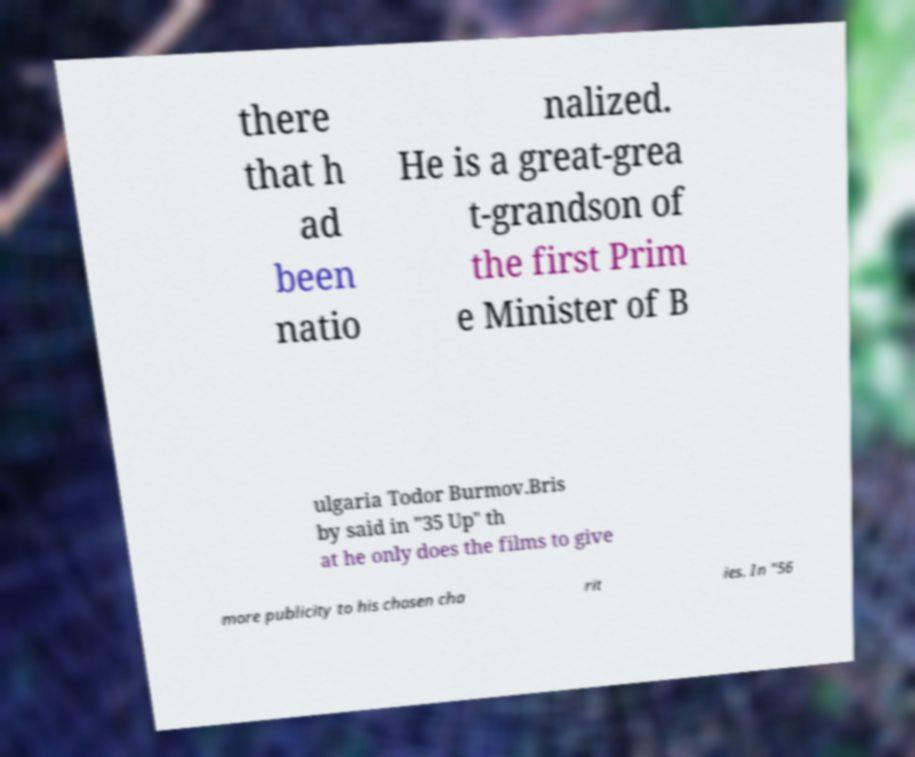Can you accurately transcribe the text from the provided image for me? there that h ad been natio nalized. He is a great-grea t-grandson of the first Prim e Minister of B ulgaria Todor Burmov.Bris by said in "35 Up" th at he only does the films to give more publicity to his chosen cha rit ies. In "56 